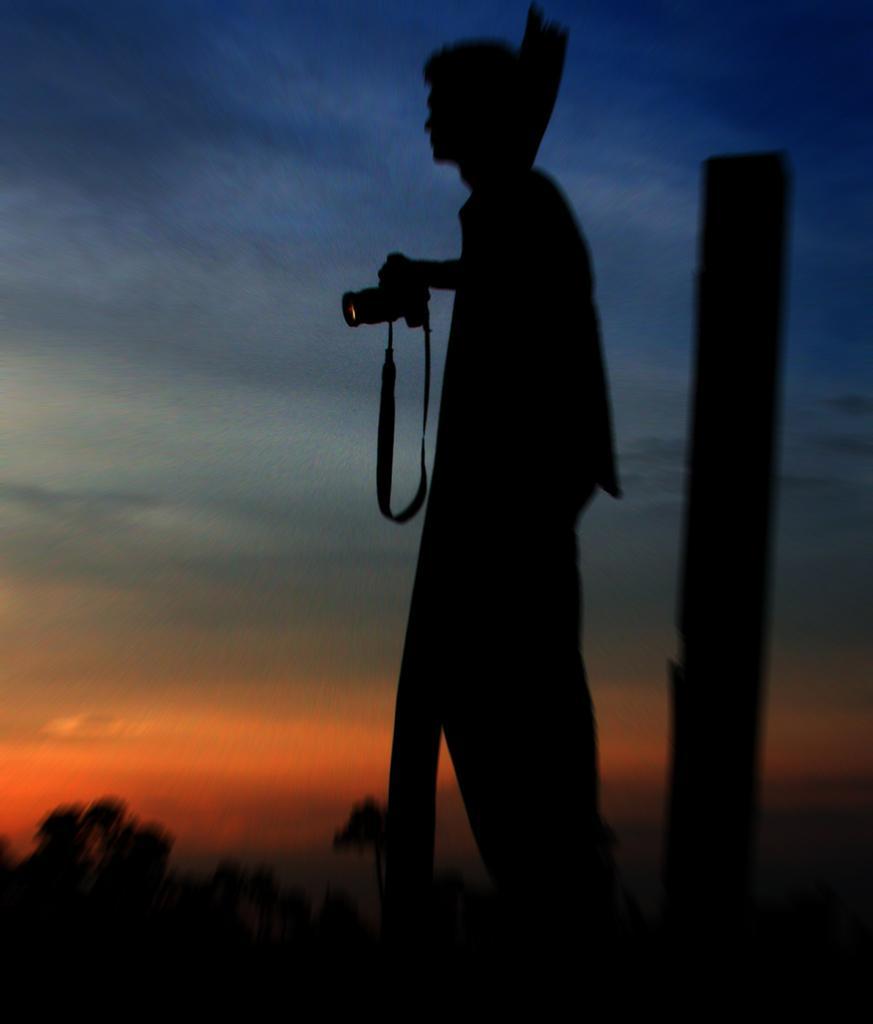In one or two sentences, can you explain what this image depicts? In this picture I see a person who is standing in front and holding a camera and in the background I see the sky and I see that this image is a bit dark. 